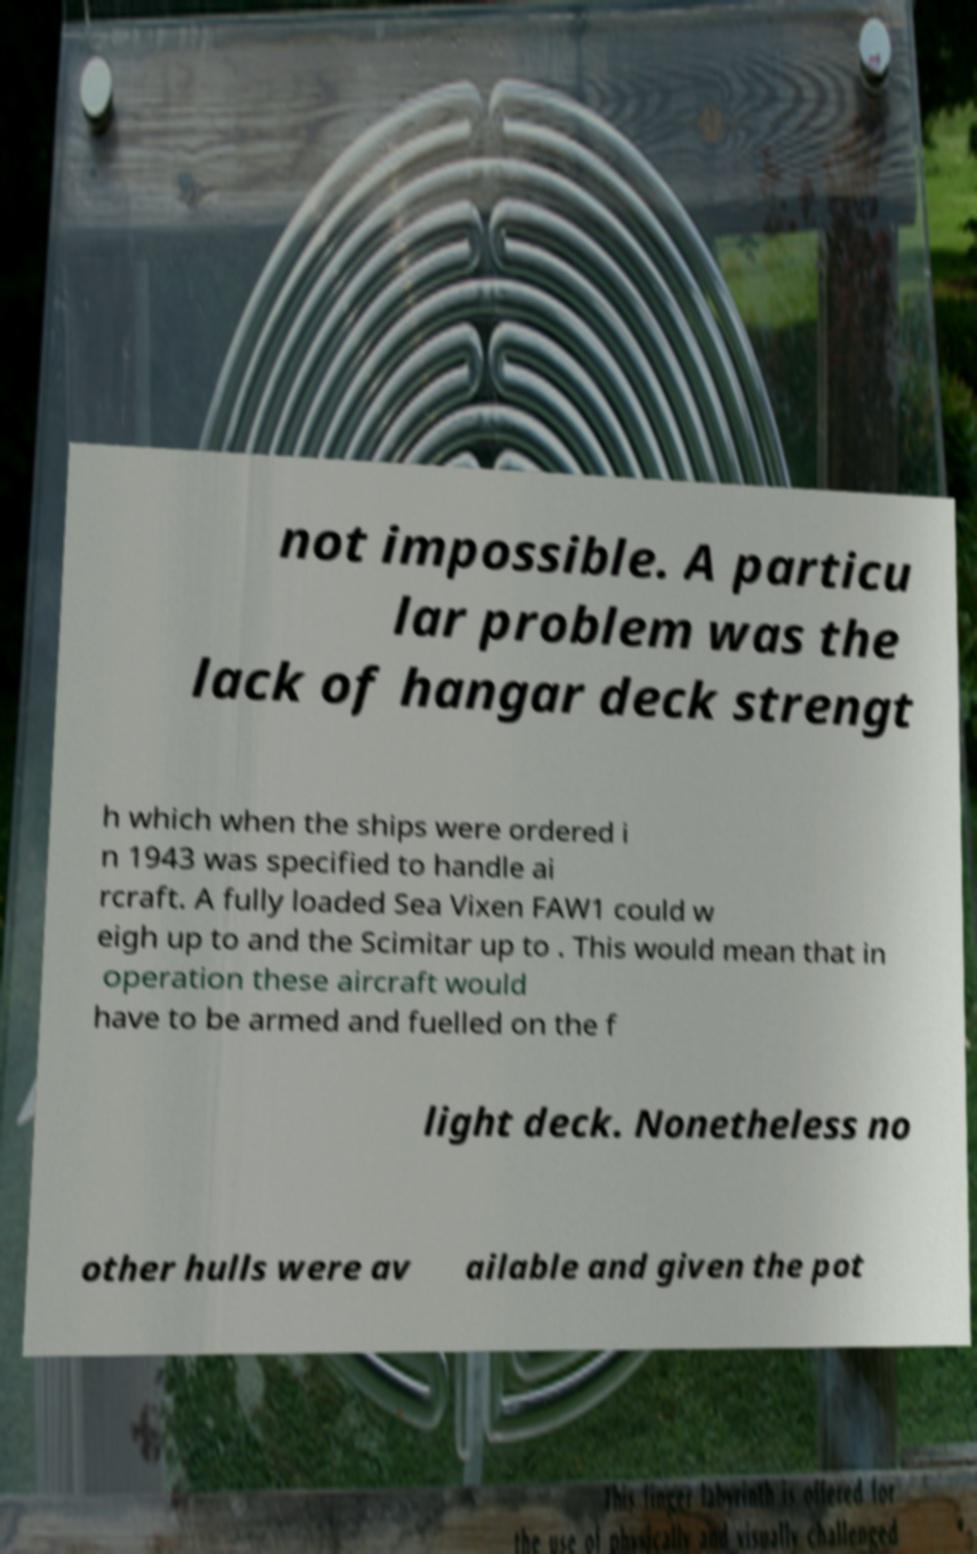I need the written content from this picture converted into text. Can you do that? not impossible. A particu lar problem was the lack of hangar deck strengt h which when the ships were ordered i n 1943 was specified to handle ai rcraft. A fully loaded Sea Vixen FAW1 could w eigh up to and the Scimitar up to . This would mean that in operation these aircraft would have to be armed and fuelled on the f light deck. Nonetheless no other hulls were av ailable and given the pot 